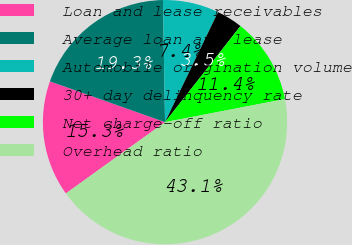Convert chart. <chart><loc_0><loc_0><loc_500><loc_500><pie_chart><fcel>Loan and lease receivables<fcel>Average loan and lease<fcel>Automobile origination volume<fcel>30+ day delinquency rate<fcel>Net charge-off ratio<fcel>Overhead ratio<nl><fcel>15.34%<fcel>19.31%<fcel>7.41%<fcel>3.45%<fcel>11.38%<fcel>43.1%<nl></chart> 